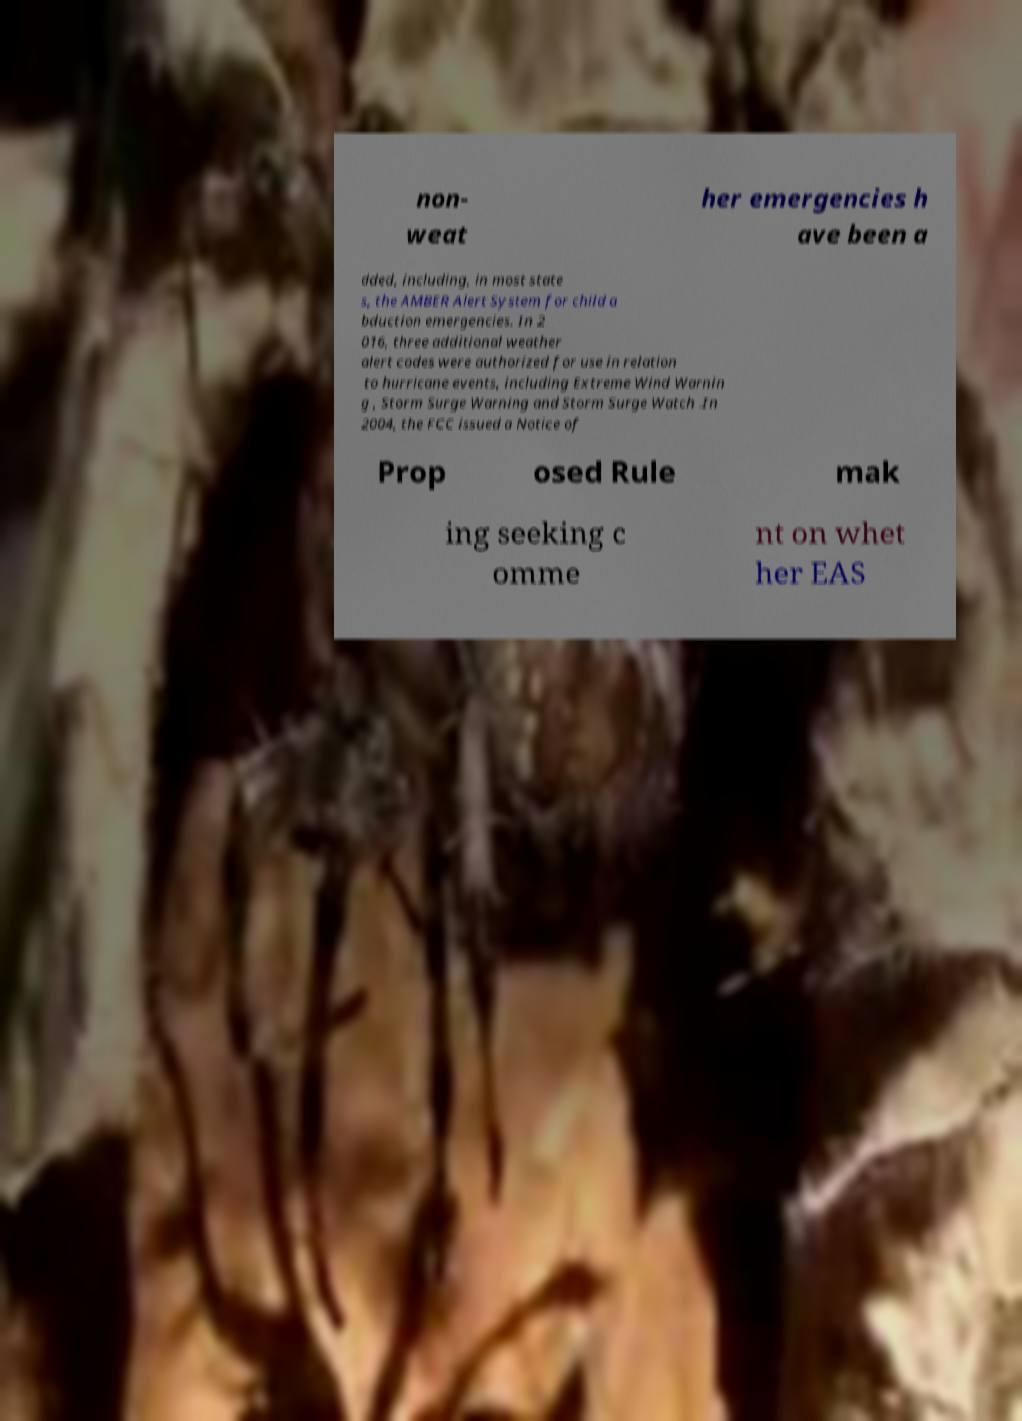There's text embedded in this image that I need extracted. Can you transcribe it verbatim? non- weat her emergencies h ave been a dded, including, in most state s, the AMBER Alert System for child a bduction emergencies. In 2 016, three additional weather alert codes were authorized for use in relation to hurricane events, including Extreme Wind Warnin g , Storm Surge Warning and Storm Surge Watch .In 2004, the FCC issued a Notice of Prop osed Rule mak ing seeking c omme nt on whet her EAS 